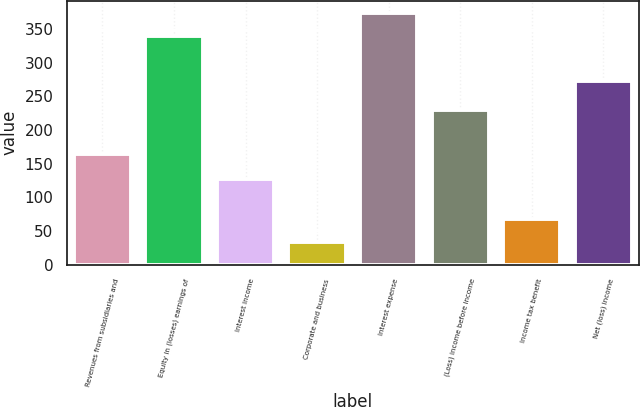<chart> <loc_0><loc_0><loc_500><loc_500><bar_chart><fcel>Revenues from subsidiaries and<fcel>Equity in (losses) earnings of<fcel>Interest income<fcel>Corporate and business<fcel>Interest expense<fcel>(Loss) income before income<fcel>Income tax benefit<fcel>Net (loss) income<nl><fcel>164<fcel>340<fcel>127<fcel>34<fcel>373.3<fcel>230<fcel>67.3<fcel>273<nl></chart> 